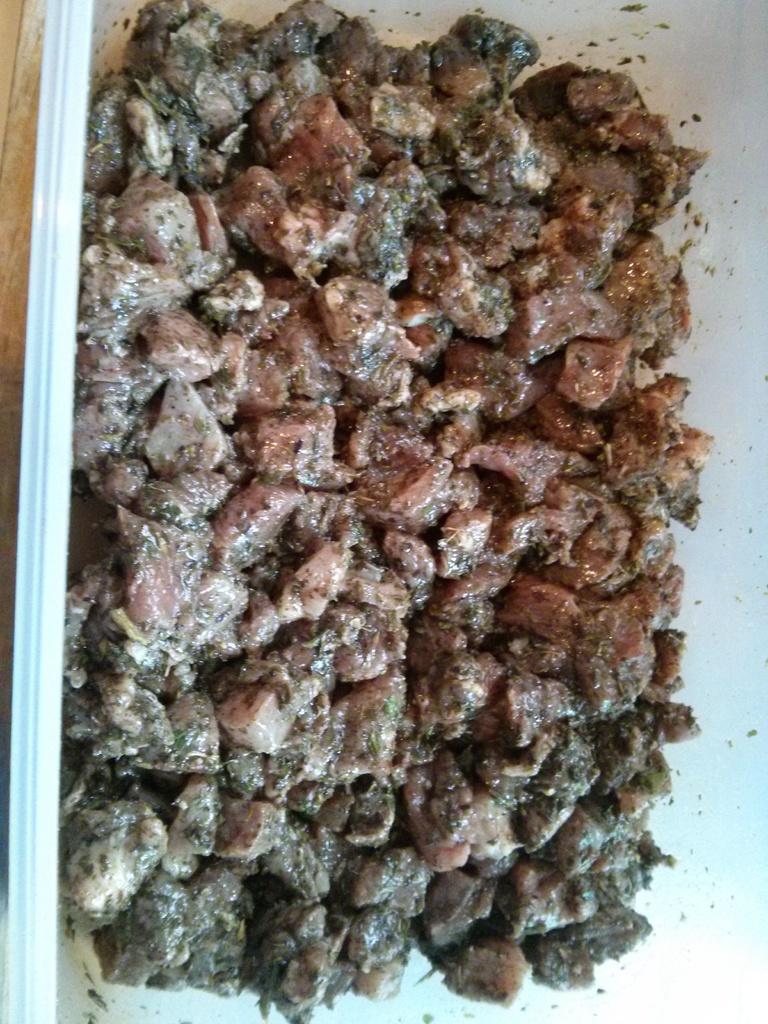Please provide a concise description of this image. In this image I can see number of brown and black colour things. 